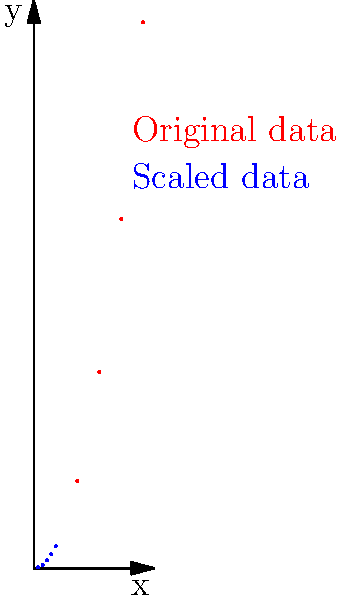As a software engineer advocating for efficiency, you're working on a clustering algorithm for a large dataset. The scatter plot shows the original data (red) and the scaled data (blue) after applying feature scaling. How does this transformation likely affect the performance of distance-based clustering algorithms like K-means? To understand the impact of feature scaling on clustering algorithms, let's analyze the transformation step-by-step:

1. Original data distribution:
   The red points show a quadratic relationship (y = x^2) with values ranging from (1,1) to (5,25).

2. Scaled data distribution:
   The blue points maintain the same shape but are compressed into a smaller range, approximately (0,0) to (1,1).

3. Effect on distance calculations:
   a) In the original data, the distances between points increase rapidly along the y-axis.
   b) In the scaled data, distances are more uniform in both x and y directions.

4. Impact on K-means clustering:
   a) K-means relies on Euclidean distance to assign points to clusters.
   b) Without scaling, the y-axis would dominate distance calculations due to its larger range.
   c) With scaling, both x and y contribute more equally to distance calculations.

5. Clustering outcome:
   a) Unscaled: Clusters would be primarily influenced by the y-axis values.
   b) Scaled: Clusters would be formed based on the relative positions of points in both dimensions.

6. Algorithm efficiency:
   a) Scaled data often leads to faster convergence in iterative algorithms like K-means.
   b) The search space is more uniform, potentially reducing the number of iterations needed.

7. Interpretation and fairness:
   Scaled features ensure that each dimension contributes proportionally to the clustering result, preventing one feature from dominating due to its larger scale.

In conclusion, feature scaling generally improves the performance, efficiency, and fairness of distance-based clustering algorithms by normalizing the contribution of each feature to the distance calculations.
Answer: Improves performance by equalizing feature contributions, leading to more balanced clustering and faster convergence. 